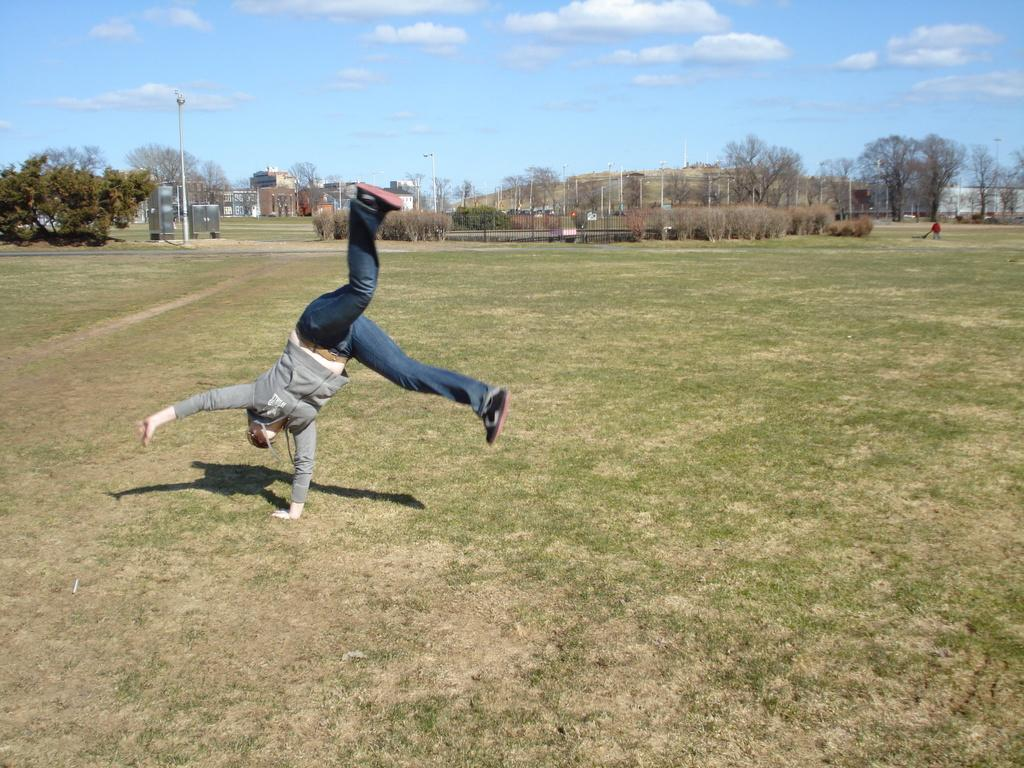Who or what is present in the image? There is a person in the image. What type of terrain is visible at the bottom of the image? There is grass at the bottom of the image. What can be seen in the background of the image? There are trees in the background of the image. What object is present in the image that might be used for support or attachment? There is a pole in the image. What is visible at the top of the image? The sky is visible at the top of the image. What type of print can be seen on the person's shirt in the image? There is no information about the person's shirt or any print on it in the provided facts. 